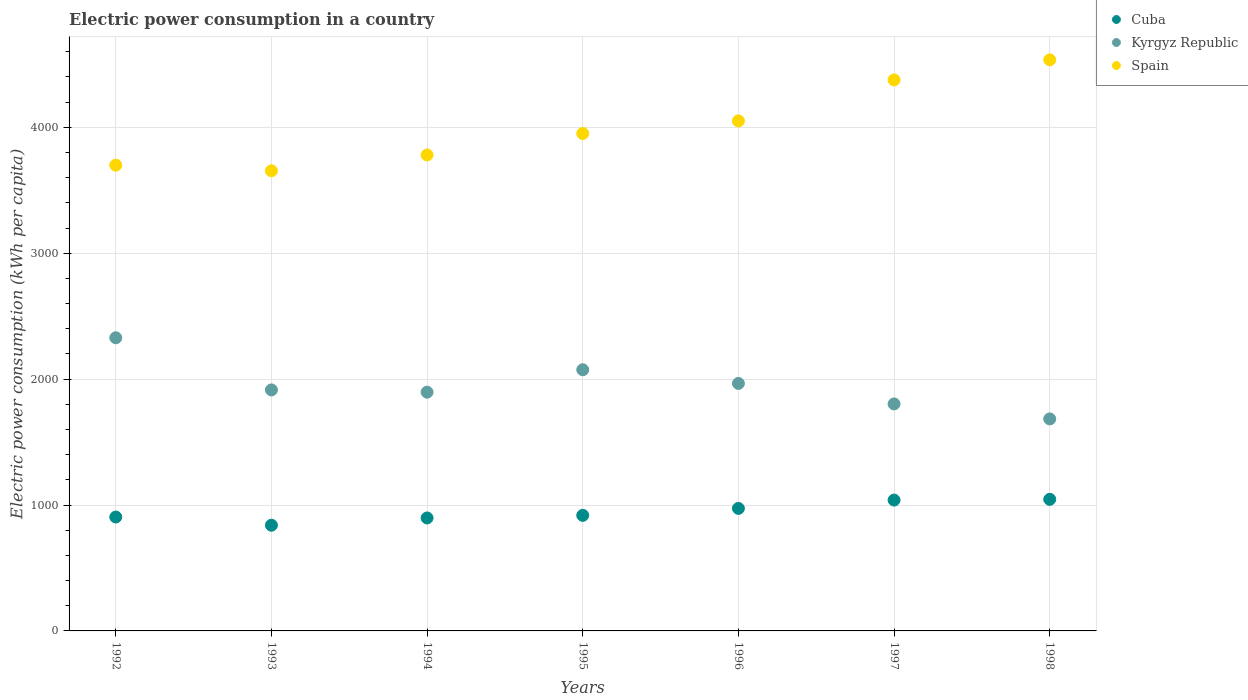Is the number of dotlines equal to the number of legend labels?
Keep it short and to the point. Yes. What is the electric power consumption in in Spain in 1997?
Ensure brevity in your answer.  4376.31. Across all years, what is the maximum electric power consumption in in Spain?
Give a very brief answer. 4535.7. Across all years, what is the minimum electric power consumption in in Spain?
Provide a short and direct response. 3654.48. In which year was the electric power consumption in in Kyrgyz Republic maximum?
Your answer should be very brief. 1992. In which year was the electric power consumption in in Cuba minimum?
Give a very brief answer. 1993. What is the total electric power consumption in in Cuba in the graph?
Your answer should be compact. 6616.54. What is the difference between the electric power consumption in in Cuba in 1994 and that in 1997?
Offer a very short reply. -142. What is the difference between the electric power consumption in in Cuba in 1994 and the electric power consumption in in Spain in 1996?
Offer a terse response. -3153.52. What is the average electric power consumption in in Spain per year?
Keep it short and to the point. 4006.79. In the year 1998, what is the difference between the electric power consumption in in Cuba and electric power consumption in in Spain?
Ensure brevity in your answer.  -3490.59. In how many years, is the electric power consumption in in Cuba greater than 3800 kWh per capita?
Ensure brevity in your answer.  0. What is the ratio of the electric power consumption in in Spain in 1992 to that in 1996?
Your response must be concise. 0.91. Is the electric power consumption in in Kyrgyz Republic in 1994 less than that in 1996?
Give a very brief answer. Yes. What is the difference between the highest and the second highest electric power consumption in in Spain?
Provide a succinct answer. 159.39. What is the difference between the highest and the lowest electric power consumption in in Kyrgyz Republic?
Keep it short and to the point. 644.25. Is the sum of the electric power consumption in in Cuba in 1993 and 1995 greater than the maximum electric power consumption in in Kyrgyz Republic across all years?
Offer a very short reply. No. Is the electric power consumption in in Kyrgyz Republic strictly less than the electric power consumption in in Cuba over the years?
Give a very brief answer. No. How many years are there in the graph?
Give a very brief answer. 7. What is the difference between two consecutive major ticks on the Y-axis?
Make the answer very short. 1000. Does the graph contain any zero values?
Your answer should be compact. No. Does the graph contain grids?
Give a very brief answer. Yes. What is the title of the graph?
Offer a very short reply. Electric power consumption in a country. What is the label or title of the Y-axis?
Keep it short and to the point. Electric power consumption (kWh per capita). What is the Electric power consumption (kWh per capita) of Cuba in 1992?
Provide a short and direct response. 904.55. What is the Electric power consumption (kWh per capita) in Kyrgyz Republic in 1992?
Provide a succinct answer. 2328.25. What is the Electric power consumption (kWh per capita) in Spain in 1992?
Provide a succinct answer. 3699.09. What is the Electric power consumption (kWh per capita) of Cuba in 1993?
Offer a very short reply. 839.54. What is the Electric power consumption (kWh per capita) in Kyrgyz Republic in 1993?
Your answer should be very brief. 1914.23. What is the Electric power consumption (kWh per capita) in Spain in 1993?
Your answer should be compact. 3654.48. What is the Electric power consumption (kWh per capita) in Cuba in 1994?
Keep it short and to the point. 897.23. What is the Electric power consumption (kWh per capita) of Kyrgyz Republic in 1994?
Offer a terse response. 1896.3. What is the Electric power consumption (kWh per capita) in Spain in 1994?
Your answer should be compact. 3780.33. What is the Electric power consumption (kWh per capita) of Cuba in 1995?
Provide a succinct answer. 917.84. What is the Electric power consumption (kWh per capita) in Kyrgyz Republic in 1995?
Provide a short and direct response. 2074.38. What is the Electric power consumption (kWh per capita) in Spain in 1995?
Your answer should be compact. 3950.85. What is the Electric power consumption (kWh per capita) in Cuba in 1996?
Offer a terse response. 973.04. What is the Electric power consumption (kWh per capita) in Kyrgyz Republic in 1996?
Make the answer very short. 1965.69. What is the Electric power consumption (kWh per capita) in Spain in 1996?
Make the answer very short. 4050.74. What is the Electric power consumption (kWh per capita) of Cuba in 1997?
Offer a terse response. 1039.23. What is the Electric power consumption (kWh per capita) of Kyrgyz Republic in 1997?
Offer a terse response. 1802.87. What is the Electric power consumption (kWh per capita) of Spain in 1997?
Your answer should be compact. 4376.31. What is the Electric power consumption (kWh per capita) in Cuba in 1998?
Provide a short and direct response. 1045.11. What is the Electric power consumption (kWh per capita) of Kyrgyz Republic in 1998?
Provide a succinct answer. 1684. What is the Electric power consumption (kWh per capita) of Spain in 1998?
Offer a very short reply. 4535.7. Across all years, what is the maximum Electric power consumption (kWh per capita) in Cuba?
Make the answer very short. 1045.11. Across all years, what is the maximum Electric power consumption (kWh per capita) in Kyrgyz Republic?
Your answer should be compact. 2328.25. Across all years, what is the maximum Electric power consumption (kWh per capita) of Spain?
Provide a short and direct response. 4535.7. Across all years, what is the minimum Electric power consumption (kWh per capita) in Cuba?
Your answer should be compact. 839.54. Across all years, what is the minimum Electric power consumption (kWh per capita) of Kyrgyz Republic?
Your answer should be compact. 1684. Across all years, what is the minimum Electric power consumption (kWh per capita) in Spain?
Make the answer very short. 3654.48. What is the total Electric power consumption (kWh per capita) in Cuba in the graph?
Your response must be concise. 6616.54. What is the total Electric power consumption (kWh per capita) of Kyrgyz Republic in the graph?
Your answer should be very brief. 1.37e+04. What is the total Electric power consumption (kWh per capita) of Spain in the graph?
Make the answer very short. 2.80e+04. What is the difference between the Electric power consumption (kWh per capita) in Cuba in 1992 and that in 1993?
Your response must be concise. 65. What is the difference between the Electric power consumption (kWh per capita) of Kyrgyz Republic in 1992 and that in 1993?
Keep it short and to the point. 414.02. What is the difference between the Electric power consumption (kWh per capita) of Spain in 1992 and that in 1993?
Give a very brief answer. 44.6. What is the difference between the Electric power consumption (kWh per capita) in Cuba in 1992 and that in 1994?
Ensure brevity in your answer.  7.32. What is the difference between the Electric power consumption (kWh per capita) in Kyrgyz Republic in 1992 and that in 1994?
Keep it short and to the point. 431.95. What is the difference between the Electric power consumption (kWh per capita) in Spain in 1992 and that in 1994?
Provide a short and direct response. -81.24. What is the difference between the Electric power consumption (kWh per capita) in Cuba in 1992 and that in 1995?
Give a very brief answer. -13.29. What is the difference between the Electric power consumption (kWh per capita) in Kyrgyz Republic in 1992 and that in 1995?
Your answer should be very brief. 253.88. What is the difference between the Electric power consumption (kWh per capita) in Spain in 1992 and that in 1995?
Offer a very short reply. -251.76. What is the difference between the Electric power consumption (kWh per capita) in Cuba in 1992 and that in 1996?
Offer a terse response. -68.49. What is the difference between the Electric power consumption (kWh per capita) in Kyrgyz Republic in 1992 and that in 1996?
Make the answer very short. 362.56. What is the difference between the Electric power consumption (kWh per capita) in Spain in 1992 and that in 1996?
Give a very brief answer. -351.66. What is the difference between the Electric power consumption (kWh per capita) in Cuba in 1992 and that in 1997?
Provide a short and direct response. -134.69. What is the difference between the Electric power consumption (kWh per capita) of Kyrgyz Republic in 1992 and that in 1997?
Offer a terse response. 525.38. What is the difference between the Electric power consumption (kWh per capita) in Spain in 1992 and that in 1997?
Make the answer very short. -677.23. What is the difference between the Electric power consumption (kWh per capita) in Cuba in 1992 and that in 1998?
Ensure brevity in your answer.  -140.56. What is the difference between the Electric power consumption (kWh per capita) in Kyrgyz Republic in 1992 and that in 1998?
Offer a terse response. 644.25. What is the difference between the Electric power consumption (kWh per capita) in Spain in 1992 and that in 1998?
Your answer should be very brief. -836.61. What is the difference between the Electric power consumption (kWh per capita) of Cuba in 1993 and that in 1994?
Make the answer very short. -57.69. What is the difference between the Electric power consumption (kWh per capita) of Kyrgyz Republic in 1993 and that in 1994?
Offer a terse response. 17.93. What is the difference between the Electric power consumption (kWh per capita) in Spain in 1993 and that in 1994?
Your response must be concise. -125.85. What is the difference between the Electric power consumption (kWh per capita) of Cuba in 1993 and that in 1995?
Make the answer very short. -78.3. What is the difference between the Electric power consumption (kWh per capita) of Kyrgyz Republic in 1993 and that in 1995?
Make the answer very short. -160.15. What is the difference between the Electric power consumption (kWh per capita) in Spain in 1993 and that in 1995?
Your response must be concise. -296.36. What is the difference between the Electric power consumption (kWh per capita) in Cuba in 1993 and that in 1996?
Ensure brevity in your answer.  -133.5. What is the difference between the Electric power consumption (kWh per capita) in Kyrgyz Republic in 1993 and that in 1996?
Keep it short and to the point. -51.46. What is the difference between the Electric power consumption (kWh per capita) of Spain in 1993 and that in 1996?
Offer a terse response. -396.26. What is the difference between the Electric power consumption (kWh per capita) of Cuba in 1993 and that in 1997?
Your answer should be compact. -199.69. What is the difference between the Electric power consumption (kWh per capita) in Kyrgyz Republic in 1993 and that in 1997?
Ensure brevity in your answer.  111.36. What is the difference between the Electric power consumption (kWh per capita) of Spain in 1993 and that in 1997?
Make the answer very short. -721.83. What is the difference between the Electric power consumption (kWh per capita) of Cuba in 1993 and that in 1998?
Make the answer very short. -205.57. What is the difference between the Electric power consumption (kWh per capita) of Kyrgyz Republic in 1993 and that in 1998?
Provide a succinct answer. 230.23. What is the difference between the Electric power consumption (kWh per capita) of Spain in 1993 and that in 1998?
Keep it short and to the point. -881.22. What is the difference between the Electric power consumption (kWh per capita) in Cuba in 1994 and that in 1995?
Give a very brief answer. -20.61. What is the difference between the Electric power consumption (kWh per capita) of Kyrgyz Republic in 1994 and that in 1995?
Make the answer very short. -178.08. What is the difference between the Electric power consumption (kWh per capita) of Spain in 1994 and that in 1995?
Your answer should be compact. -170.51. What is the difference between the Electric power consumption (kWh per capita) in Cuba in 1994 and that in 1996?
Provide a short and direct response. -75.81. What is the difference between the Electric power consumption (kWh per capita) of Kyrgyz Republic in 1994 and that in 1996?
Provide a succinct answer. -69.39. What is the difference between the Electric power consumption (kWh per capita) in Spain in 1994 and that in 1996?
Keep it short and to the point. -270.41. What is the difference between the Electric power consumption (kWh per capita) of Cuba in 1994 and that in 1997?
Provide a succinct answer. -142. What is the difference between the Electric power consumption (kWh per capita) in Kyrgyz Republic in 1994 and that in 1997?
Provide a short and direct response. 93.43. What is the difference between the Electric power consumption (kWh per capita) of Spain in 1994 and that in 1997?
Provide a succinct answer. -595.98. What is the difference between the Electric power consumption (kWh per capita) of Cuba in 1994 and that in 1998?
Keep it short and to the point. -147.88. What is the difference between the Electric power consumption (kWh per capita) in Kyrgyz Republic in 1994 and that in 1998?
Your answer should be compact. 212.3. What is the difference between the Electric power consumption (kWh per capita) in Spain in 1994 and that in 1998?
Your answer should be compact. -755.37. What is the difference between the Electric power consumption (kWh per capita) of Cuba in 1995 and that in 1996?
Your answer should be compact. -55.2. What is the difference between the Electric power consumption (kWh per capita) of Kyrgyz Republic in 1995 and that in 1996?
Make the answer very short. 108.69. What is the difference between the Electric power consumption (kWh per capita) in Spain in 1995 and that in 1996?
Give a very brief answer. -99.9. What is the difference between the Electric power consumption (kWh per capita) of Cuba in 1995 and that in 1997?
Ensure brevity in your answer.  -121.39. What is the difference between the Electric power consumption (kWh per capita) of Kyrgyz Republic in 1995 and that in 1997?
Provide a short and direct response. 271.51. What is the difference between the Electric power consumption (kWh per capita) in Spain in 1995 and that in 1997?
Give a very brief answer. -425.47. What is the difference between the Electric power consumption (kWh per capita) of Cuba in 1995 and that in 1998?
Your answer should be compact. -127.27. What is the difference between the Electric power consumption (kWh per capita) in Kyrgyz Republic in 1995 and that in 1998?
Your answer should be very brief. 390.38. What is the difference between the Electric power consumption (kWh per capita) of Spain in 1995 and that in 1998?
Provide a short and direct response. -584.85. What is the difference between the Electric power consumption (kWh per capita) of Cuba in 1996 and that in 1997?
Your answer should be compact. -66.19. What is the difference between the Electric power consumption (kWh per capita) in Kyrgyz Republic in 1996 and that in 1997?
Your response must be concise. 162.82. What is the difference between the Electric power consumption (kWh per capita) of Spain in 1996 and that in 1997?
Your answer should be compact. -325.57. What is the difference between the Electric power consumption (kWh per capita) of Cuba in 1996 and that in 1998?
Provide a short and direct response. -72.07. What is the difference between the Electric power consumption (kWh per capita) in Kyrgyz Republic in 1996 and that in 1998?
Give a very brief answer. 281.69. What is the difference between the Electric power consumption (kWh per capita) in Spain in 1996 and that in 1998?
Offer a terse response. -484.96. What is the difference between the Electric power consumption (kWh per capita) in Cuba in 1997 and that in 1998?
Keep it short and to the point. -5.88. What is the difference between the Electric power consumption (kWh per capita) in Kyrgyz Republic in 1997 and that in 1998?
Your answer should be compact. 118.87. What is the difference between the Electric power consumption (kWh per capita) in Spain in 1997 and that in 1998?
Your answer should be very brief. -159.39. What is the difference between the Electric power consumption (kWh per capita) of Cuba in 1992 and the Electric power consumption (kWh per capita) of Kyrgyz Republic in 1993?
Ensure brevity in your answer.  -1009.68. What is the difference between the Electric power consumption (kWh per capita) in Cuba in 1992 and the Electric power consumption (kWh per capita) in Spain in 1993?
Your answer should be compact. -2749.94. What is the difference between the Electric power consumption (kWh per capita) in Kyrgyz Republic in 1992 and the Electric power consumption (kWh per capita) in Spain in 1993?
Your response must be concise. -1326.23. What is the difference between the Electric power consumption (kWh per capita) of Cuba in 1992 and the Electric power consumption (kWh per capita) of Kyrgyz Republic in 1994?
Provide a succinct answer. -991.76. What is the difference between the Electric power consumption (kWh per capita) in Cuba in 1992 and the Electric power consumption (kWh per capita) in Spain in 1994?
Your response must be concise. -2875.79. What is the difference between the Electric power consumption (kWh per capita) of Kyrgyz Republic in 1992 and the Electric power consumption (kWh per capita) of Spain in 1994?
Your response must be concise. -1452.08. What is the difference between the Electric power consumption (kWh per capita) of Cuba in 1992 and the Electric power consumption (kWh per capita) of Kyrgyz Republic in 1995?
Ensure brevity in your answer.  -1169.83. What is the difference between the Electric power consumption (kWh per capita) of Cuba in 1992 and the Electric power consumption (kWh per capita) of Spain in 1995?
Offer a terse response. -3046.3. What is the difference between the Electric power consumption (kWh per capita) of Kyrgyz Republic in 1992 and the Electric power consumption (kWh per capita) of Spain in 1995?
Provide a succinct answer. -1622.59. What is the difference between the Electric power consumption (kWh per capita) of Cuba in 1992 and the Electric power consumption (kWh per capita) of Kyrgyz Republic in 1996?
Provide a succinct answer. -1061.14. What is the difference between the Electric power consumption (kWh per capita) in Cuba in 1992 and the Electric power consumption (kWh per capita) in Spain in 1996?
Your response must be concise. -3146.2. What is the difference between the Electric power consumption (kWh per capita) in Kyrgyz Republic in 1992 and the Electric power consumption (kWh per capita) in Spain in 1996?
Provide a succinct answer. -1722.49. What is the difference between the Electric power consumption (kWh per capita) in Cuba in 1992 and the Electric power consumption (kWh per capita) in Kyrgyz Republic in 1997?
Provide a short and direct response. -898.32. What is the difference between the Electric power consumption (kWh per capita) of Cuba in 1992 and the Electric power consumption (kWh per capita) of Spain in 1997?
Your response must be concise. -3471.77. What is the difference between the Electric power consumption (kWh per capita) in Kyrgyz Republic in 1992 and the Electric power consumption (kWh per capita) in Spain in 1997?
Provide a short and direct response. -2048.06. What is the difference between the Electric power consumption (kWh per capita) in Cuba in 1992 and the Electric power consumption (kWh per capita) in Kyrgyz Republic in 1998?
Offer a terse response. -779.46. What is the difference between the Electric power consumption (kWh per capita) of Cuba in 1992 and the Electric power consumption (kWh per capita) of Spain in 1998?
Offer a terse response. -3631.15. What is the difference between the Electric power consumption (kWh per capita) in Kyrgyz Republic in 1992 and the Electric power consumption (kWh per capita) in Spain in 1998?
Provide a succinct answer. -2207.44. What is the difference between the Electric power consumption (kWh per capita) in Cuba in 1993 and the Electric power consumption (kWh per capita) in Kyrgyz Republic in 1994?
Your answer should be compact. -1056.76. What is the difference between the Electric power consumption (kWh per capita) of Cuba in 1993 and the Electric power consumption (kWh per capita) of Spain in 1994?
Your response must be concise. -2940.79. What is the difference between the Electric power consumption (kWh per capita) of Kyrgyz Republic in 1993 and the Electric power consumption (kWh per capita) of Spain in 1994?
Ensure brevity in your answer.  -1866.1. What is the difference between the Electric power consumption (kWh per capita) of Cuba in 1993 and the Electric power consumption (kWh per capita) of Kyrgyz Republic in 1995?
Ensure brevity in your answer.  -1234.84. What is the difference between the Electric power consumption (kWh per capita) of Cuba in 1993 and the Electric power consumption (kWh per capita) of Spain in 1995?
Keep it short and to the point. -3111.3. What is the difference between the Electric power consumption (kWh per capita) of Kyrgyz Republic in 1993 and the Electric power consumption (kWh per capita) of Spain in 1995?
Ensure brevity in your answer.  -2036.62. What is the difference between the Electric power consumption (kWh per capita) in Cuba in 1993 and the Electric power consumption (kWh per capita) in Kyrgyz Republic in 1996?
Your response must be concise. -1126.15. What is the difference between the Electric power consumption (kWh per capita) of Cuba in 1993 and the Electric power consumption (kWh per capita) of Spain in 1996?
Your answer should be compact. -3211.2. What is the difference between the Electric power consumption (kWh per capita) of Kyrgyz Republic in 1993 and the Electric power consumption (kWh per capita) of Spain in 1996?
Keep it short and to the point. -2136.51. What is the difference between the Electric power consumption (kWh per capita) in Cuba in 1993 and the Electric power consumption (kWh per capita) in Kyrgyz Republic in 1997?
Your answer should be compact. -963.33. What is the difference between the Electric power consumption (kWh per capita) of Cuba in 1993 and the Electric power consumption (kWh per capita) of Spain in 1997?
Give a very brief answer. -3536.77. What is the difference between the Electric power consumption (kWh per capita) in Kyrgyz Republic in 1993 and the Electric power consumption (kWh per capita) in Spain in 1997?
Provide a succinct answer. -2462.08. What is the difference between the Electric power consumption (kWh per capita) of Cuba in 1993 and the Electric power consumption (kWh per capita) of Kyrgyz Republic in 1998?
Keep it short and to the point. -844.46. What is the difference between the Electric power consumption (kWh per capita) of Cuba in 1993 and the Electric power consumption (kWh per capita) of Spain in 1998?
Offer a terse response. -3696.16. What is the difference between the Electric power consumption (kWh per capita) in Kyrgyz Republic in 1993 and the Electric power consumption (kWh per capita) in Spain in 1998?
Your answer should be very brief. -2621.47. What is the difference between the Electric power consumption (kWh per capita) in Cuba in 1994 and the Electric power consumption (kWh per capita) in Kyrgyz Republic in 1995?
Offer a very short reply. -1177.15. What is the difference between the Electric power consumption (kWh per capita) in Cuba in 1994 and the Electric power consumption (kWh per capita) in Spain in 1995?
Your answer should be compact. -3053.62. What is the difference between the Electric power consumption (kWh per capita) of Kyrgyz Republic in 1994 and the Electric power consumption (kWh per capita) of Spain in 1995?
Ensure brevity in your answer.  -2054.54. What is the difference between the Electric power consumption (kWh per capita) in Cuba in 1994 and the Electric power consumption (kWh per capita) in Kyrgyz Republic in 1996?
Provide a short and direct response. -1068.46. What is the difference between the Electric power consumption (kWh per capita) in Cuba in 1994 and the Electric power consumption (kWh per capita) in Spain in 1996?
Provide a succinct answer. -3153.52. What is the difference between the Electric power consumption (kWh per capita) of Kyrgyz Republic in 1994 and the Electric power consumption (kWh per capita) of Spain in 1996?
Your answer should be compact. -2154.44. What is the difference between the Electric power consumption (kWh per capita) in Cuba in 1994 and the Electric power consumption (kWh per capita) in Kyrgyz Republic in 1997?
Your answer should be very brief. -905.64. What is the difference between the Electric power consumption (kWh per capita) in Cuba in 1994 and the Electric power consumption (kWh per capita) in Spain in 1997?
Make the answer very short. -3479.08. What is the difference between the Electric power consumption (kWh per capita) of Kyrgyz Republic in 1994 and the Electric power consumption (kWh per capita) of Spain in 1997?
Your answer should be compact. -2480.01. What is the difference between the Electric power consumption (kWh per capita) of Cuba in 1994 and the Electric power consumption (kWh per capita) of Kyrgyz Republic in 1998?
Offer a terse response. -786.77. What is the difference between the Electric power consumption (kWh per capita) of Cuba in 1994 and the Electric power consumption (kWh per capita) of Spain in 1998?
Ensure brevity in your answer.  -3638.47. What is the difference between the Electric power consumption (kWh per capita) in Kyrgyz Republic in 1994 and the Electric power consumption (kWh per capita) in Spain in 1998?
Provide a succinct answer. -2639.4. What is the difference between the Electric power consumption (kWh per capita) of Cuba in 1995 and the Electric power consumption (kWh per capita) of Kyrgyz Republic in 1996?
Provide a succinct answer. -1047.85. What is the difference between the Electric power consumption (kWh per capita) in Cuba in 1995 and the Electric power consumption (kWh per capita) in Spain in 1996?
Ensure brevity in your answer.  -3132.9. What is the difference between the Electric power consumption (kWh per capita) in Kyrgyz Republic in 1995 and the Electric power consumption (kWh per capita) in Spain in 1996?
Your answer should be compact. -1976.36. What is the difference between the Electric power consumption (kWh per capita) of Cuba in 1995 and the Electric power consumption (kWh per capita) of Kyrgyz Republic in 1997?
Provide a short and direct response. -885.03. What is the difference between the Electric power consumption (kWh per capita) in Cuba in 1995 and the Electric power consumption (kWh per capita) in Spain in 1997?
Your answer should be very brief. -3458.47. What is the difference between the Electric power consumption (kWh per capita) in Kyrgyz Republic in 1995 and the Electric power consumption (kWh per capita) in Spain in 1997?
Your answer should be very brief. -2301.93. What is the difference between the Electric power consumption (kWh per capita) in Cuba in 1995 and the Electric power consumption (kWh per capita) in Kyrgyz Republic in 1998?
Your answer should be compact. -766.16. What is the difference between the Electric power consumption (kWh per capita) in Cuba in 1995 and the Electric power consumption (kWh per capita) in Spain in 1998?
Make the answer very short. -3617.86. What is the difference between the Electric power consumption (kWh per capita) in Kyrgyz Republic in 1995 and the Electric power consumption (kWh per capita) in Spain in 1998?
Provide a succinct answer. -2461.32. What is the difference between the Electric power consumption (kWh per capita) in Cuba in 1996 and the Electric power consumption (kWh per capita) in Kyrgyz Republic in 1997?
Give a very brief answer. -829.83. What is the difference between the Electric power consumption (kWh per capita) in Cuba in 1996 and the Electric power consumption (kWh per capita) in Spain in 1997?
Offer a very short reply. -3403.27. What is the difference between the Electric power consumption (kWh per capita) in Kyrgyz Republic in 1996 and the Electric power consumption (kWh per capita) in Spain in 1997?
Ensure brevity in your answer.  -2410.62. What is the difference between the Electric power consumption (kWh per capita) of Cuba in 1996 and the Electric power consumption (kWh per capita) of Kyrgyz Republic in 1998?
Give a very brief answer. -710.96. What is the difference between the Electric power consumption (kWh per capita) in Cuba in 1996 and the Electric power consumption (kWh per capita) in Spain in 1998?
Offer a terse response. -3562.66. What is the difference between the Electric power consumption (kWh per capita) in Kyrgyz Republic in 1996 and the Electric power consumption (kWh per capita) in Spain in 1998?
Give a very brief answer. -2570.01. What is the difference between the Electric power consumption (kWh per capita) in Cuba in 1997 and the Electric power consumption (kWh per capita) in Kyrgyz Republic in 1998?
Give a very brief answer. -644.77. What is the difference between the Electric power consumption (kWh per capita) in Cuba in 1997 and the Electric power consumption (kWh per capita) in Spain in 1998?
Your response must be concise. -3496.47. What is the difference between the Electric power consumption (kWh per capita) in Kyrgyz Republic in 1997 and the Electric power consumption (kWh per capita) in Spain in 1998?
Offer a terse response. -2732.83. What is the average Electric power consumption (kWh per capita) in Cuba per year?
Provide a succinct answer. 945.22. What is the average Electric power consumption (kWh per capita) of Kyrgyz Republic per year?
Provide a succinct answer. 1952.25. What is the average Electric power consumption (kWh per capita) in Spain per year?
Ensure brevity in your answer.  4006.79. In the year 1992, what is the difference between the Electric power consumption (kWh per capita) in Cuba and Electric power consumption (kWh per capita) in Kyrgyz Republic?
Ensure brevity in your answer.  -1423.71. In the year 1992, what is the difference between the Electric power consumption (kWh per capita) of Cuba and Electric power consumption (kWh per capita) of Spain?
Offer a terse response. -2794.54. In the year 1992, what is the difference between the Electric power consumption (kWh per capita) in Kyrgyz Republic and Electric power consumption (kWh per capita) in Spain?
Offer a very short reply. -1370.83. In the year 1993, what is the difference between the Electric power consumption (kWh per capita) in Cuba and Electric power consumption (kWh per capita) in Kyrgyz Republic?
Offer a very short reply. -1074.69. In the year 1993, what is the difference between the Electric power consumption (kWh per capita) of Cuba and Electric power consumption (kWh per capita) of Spain?
Make the answer very short. -2814.94. In the year 1993, what is the difference between the Electric power consumption (kWh per capita) of Kyrgyz Republic and Electric power consumption (kWh per capita) of Spain?
Provide a succinct answer. -1740.25. In the year 1994, what is the difference between the Electric power consumption (kWh per capita) of Cuba and Electric power consumption (kWh per capita) of Kyrgyz Republic?
Offer a very short reply. -999.08. In the year 1994, what is the difference between the Electric power consumption (kWh per capita) in Cuba and Electric power consumption (kWh per capita) in Spain?
Make the answer very short. -2883.1. In the year 1994, what is the difference between the Electric power consumption (kWh per capita) of Kyrgyz Republic and Electric power consumption (kWh per capita) of Spain?
Ensure brevity in your answer.  -1884.03. In the year 1995, what is the difference between the Electric power consumption (kWh per capita) of Cuba and Electric power consumption (kWh per capita) of Kyrgyz Republic?
Make the answer very short. -1156.54. In the year 1995, what is the difference between the Electric power consumption (kWh per capita) of Cuba and Electric power consumption (kWh per capita) of Spain?
Keep it short and to the point. -3033.01. In the year 1995, what is the difference between the Electric power consumption (kWh per capita) in Kyrgyz Republic and Electric power consumption (kWh per capita) in Spain?
Your answer should be compact. -1876.47. In the year 1996, what is the difference between the Electric power consumption (kWh per capita) of Cuba and Electric power consumption (kWh per capita) of Kyrgyz Republic?
Ensure brevity in your answer.  -992.65. In the year 1996, what is the difference between the Electric power consumption (kWh per capita) of Cuba and Electric power consumption (kWh per capita) of Spain?
Offer a terse response. -3077.7. In the year 1996, what is the difference between the Electric power consumption (kWh per capita) in Kyrgyz Republic and Electric power consumption (kWh per capita) in Spain?
Your answer should be very brief. -2085.05. In the year 1997, what is the difference between the Electric power consumption (kWh per capita) of Cuba and Electric power consumption (kWh per capita) of Kyrgyz Republic?
Offer a very short reply. -763.64. In the year 1997, what is the difference between the Electric power consumption (kWh per capita) in Cuba and Electric power consumption (kWh per capita) in Spain?
Offer a terse response. -3337.08. In the year 1997, what is the difference between the Electric power consumption (kWh per capita) in Kyrgyz Republic and Electric power consumption (kWh per capita) in Spain?
Offer a very short reply. -2573.44. In the year 1998, what is the difference between the Electric power consumption (kWh per capita) of Cuba and Electric power consumption (kWh per capita) of Kyrgyz Republic?
Offer a very short reply. -638.89. In the year 1998, what is the difference between the Electric power consumption (kWh per capita) in Cuba and Electric power consumption (kWh per capita) in Spain?
Ensure brevity in your answer.  -3490.59. In the year 1998, what is the difference between the Electric power consumption (kWh per capita) in Kyrgyz Republic and Electric power consumption (kWh per capita) in Spain?
Keep it short and to the point. -2851.7. What is the ratio of the Electric power consumption (kWh per capita) in Cuba in 1992 to that in 1993?
Ensure brevity in your answer.  1.08. What is the ratio of the Electric power consumption (kWh per capita) in Kyrgyz Republic in 1992 to that in 1993?
Provide a short and direct response. 1.22. What is the ratio of the Electric power consumption (kWh per capita) of Spain in 1992 to that in 1993?
Make the answer very short. 1.01. What is the ratio of the Electric power consumption (kWh per capita) in Cuba in 1992 to that in 1994?
Keep it short and to the point. 1.01. What is the ratio of the Electric power consumption (kWh per capita) of Kyrgyz Republic in 1992 to that in 1994?
Offer a very short reply. 1.23. What is the ratio of the Electric power consumption (kWh per capita) of Spain in 1992 to that in 1994?
Your answer should be very brief. 0.98. What is the ratio of the Electric power consumption (kWh per capita) of Cuba in 1992 to that in 1995?
Offer a terse response. 0.99. What is the ratio of the Electric power consumption (kWh per capita) of Kyrgyz Republic in 1992 to that in 1995?
Your answer should be compact. 1.12. What is the ratio of the Electric power consumption (kWh per capita) of Spain in 1992 to that in 1995?
Your response must be concise. 0.94. What is the ratio of the Electric power consumption (kWh per capita) of Cuba in 1992 to that in 1996?
Offer a terse response. 0.93. What is the ratio of the Electric power consumption (kWh per capita) in Kyrgyz Republic in 1992 to that in 1996?
Provide a short and direct response. 1.18. What is the ratio of the Electric power consumption (kWh per capita) in Spain in 1992 to that in 1996?
Your answer should be compact. 0.91. What is the ratio of the Electric power consumption (kWh per capita) of Cuba in 1992 to that in 1997?
Give a very brief answer. 0.87. What is the ratio of the Electric power consumption (kWh per capita) of Kyrgyz Republic in 1992 to that in 1997?
Offer a very short reply. 1.29. What is the ratio of the Electric power consumption (kWh per capita) of Spain in 1992 to that in 1997?
Provide a short and direct response. 0.85. What is the ratio of the Electric power consumption (kWh per capita) in Cuba in 1992 to that in 1998?
Your answer should be compact. 0.87. What is the ratio of the Electric power consumption (kWh per capita) in Kyrgyz Republic in 1992 to that in 1998?
Offer a very short reply. 1.38. What is the ratio of the Electric power consumption (kWh per capita) in Spain in 1992 to that in 1998?
Provide a short and direct response. 0.82. What is the ratio of the Electric power consumption (kWh per capita) of Cuba in 1993 to that in 1994?
Give a very brief answer. 0.94. What is the ratio of the Electric power consumption (kWh per capita) in Kyrgyz Republic in 1993 to that in 1994?
Provide a short and direct response. 1.01. What is the ratio of the Electric power consumption (kWh per capita) of Spain in 1993 to that in 1994?
Ensure brevity in your answer.  0.97. What is the ratio of the Electric power consumption (kWh per capita) in Cuba in 1993 to that in 1995?
Provide a succinct answer. 0.91. What is the ratio of the Electric power consumption (kWh per capita) in Kyrgyz Republic in 1993 to that in 1995?
Your answer should be compact. 0.92. What is the ratio of the Electric power consumption (kWh per capita) of Spain in 1993 to that in 1995?
Provide a succinct answer. 0.93. What is the ratio of the Electric power consumption (kWh per capita) of Cuba in 1993 to that in 1996?
Your answer should be compact. 0.86. What is the ratio of the Electric power consumption (kWh per capita) in Kyrgyz Republic in 1993 to that in 1996?
Provide a short and direct response. 0.97. What is the ratio of the Electric power consumption (kWh per capita) in Spain in 1993 to that in 1996?
Ensure brevity in your answer.  0.9. What is the ratio of the Electric power consumption (kWh per capita) in Cuba in 1993 to that in 1997?
Give a very brief answer. 0.81. What is the ratio of the Electric power consumption (kWh per capita) in Kyrgyz Republic in 1993 to that in 1997?
Keep it short and to the point. 1.06. What is the ratio of the Electric power consumption (kWh per capita) in Spain in 1993 to that in 1997?
Your answer should be compact. 0.84. What is the ratio of the Electric power consumption (kWh per capita) of Cuba in 1993 to that in 1998?
Your answer should be compact. 0.8. What is the ratio of the Electric power consumption (kWh per capita) of Kyrgyz Republic in 1993 to that in 1998?
Your answer should be compact. 1.14. What is the ratio of the Electric power consumption (kWh per capita) of Spain in 1993 to that in 1998?
Provide a succinct answer. 0.81. What is the ratio of the Electric power consumption (kWh per capita) of Cuba in 1994 to that in 1995?
Provide a succinct answer. 0.98. What is the ratio of the Electric power consumption (kWh per capita) of Kyrgyz Republic in 1994 to that in 1995?
Make the answer very short. 0.91. What is the ratio of the Electric power consumption (kWh per capita) of Spain in 1994 to that in 1995?
Give a very brief answer. 0.96. What is the ratio of the Electric power consumption (kWh per capita) of Cuba in 1994 to that in 1996?
Offer a very short reply. 0.92. What is the ratio of the Electric power consumption (kWh per capita) of Kyrgyz Republic in 1994 to that in 1996?
Your answer should be compact. 0.96. What is the ratio of the Electric power consumption (kWh per capita) in Spain in 1994 to that in 1996?
Provide a short and direct response. 0.93. What is the ratio of the Electric power consumption (kWh per capita) in Cuba in 1994 to that in 1997?
Give a very brief answer. 0.86. What is the ratio of the Electric power consumption (kWh per capita) of Kyrgyz Republic in 1994 to that in 1997?
Provide a short and direct response. 1.05. What is the ratio of the Electric power consumption (kWh per capita) in Spain in 1994 to that in 1997?
Your response must be concise. 0.86. What is the ratio of the Electric power consumption (kWh per capita) in Cuba in 1994 to that in 1998?
Your answer should be compact. 0.86. What is the ratio of the Electric power consumption (kWh per capita) in Kyrgyz Republic in 1994 to that in 1998?
Offer a terse response. 1.13. What is the ratio of the Electric power consumption (kWh per capita) of Spain in 1994 to that in 1998?
Offer a terse response. 0.83. What is the ratio of the Electric power consumption (kWh per capita) of Cuba in 1995 to that in 1996?
Ensure brevity in your answer.  0.94. What is the ratio of the Electric power consumption (kWh per capita) in Kyrgyz Republic in 1995 to that in 1996?
Your answer should be very brief. 1.06. What is the ratio of the Electric power consumption (kWh per capita) of Spain in 1995 to that in 1996?
Provide a succinct answer. 0.98. What is the ratio of the Electric power consumption (kWh per capita) in Cuba in 1995 to that in 1997?
Your response must be concise. 0.88. What is the ratio of the Electric power consumption (kWh per capita) in Kyrgyz Republic in 1995 to that in 1997?
Give a very brief answer. 1.15. What is the ratio of the Electric power consumption (kWh per capita) in Spain in 1995 to that in 1997?
Give a very brief answer. 0.9. What is the ratio of the Electric power consumption (kWh per capita) in Cuba in 1995 to that in 1998?
Keep it short and to the point. 0.88. What is the ratio of the Electric power consumption (kWh per capita) of Kyrgyz Republic in 1995 to that in 1998?
Offer a very short reply. 1.23. What is the ratio of the Electric power consumption (kWh per capita) in Spain in 1995 to that in 1998?
Make the answer very short. 0.87. What is the ratio of the Electric power consumption (kWh per capita) in Cuba in 1996 to that in 1997?
Your answer should be compact. 0.94. What is the ratio of the Electric power consumption (kWh per capita) in Kyrgyz Republic in 1996 to that in 1997?
Provide a short and direct response. 1.09. What is the ratio of the Electric power consumption (kWh per capita) in Spain in 1996 to that in 1997?
Make the answer very short. 0.93. What is the ratio of the Electric power consumption (kWh per capita) in Kyrgyz Republic in 1996 to that in 1998?
Your answer should be very brief. 1.17. What is the ratio of the Electric power consumption (kWh per capita) in Spain in 1996 to that in 1998?
Offer a terse response. 0.89. What is the ratio of the Electric power consumption (kWh per capita) in Cuba in 1997 to that in 1998?
Your answer should be very brief. 0.99. What is the ratio of the Electric power consumption (kWh per capita) of Kyrgyz Republic in 1997 to that in 1998?
Your response must be concise. 1.07. What is the ratio of the Electric power consumption (kWh per capita) in Spain in 1997 to that in 1998?
Your answer should be compact. 0.96. What is the difference between the highest and the second highest Electric power consumption (kWh per capita) of Cuba?
Provide a short and direct response. 5.88. What is the difference between the highest and the second highest Electric power consumption (kWh per capita) of Kyrgyz Republic?
Give a very brief answer. 253.88. What is the difference between the highest and the second highest Electric power consumption (kWh per capita) of Spain?
Your answer should be very brief. 159.39. What is the difference between the highest and the lowest Electric power consumption (kWh per capita) of Cuba?
Ensure brevity in your answer.  205.57. What is the difference between the highest and the lowest Electric power consumption (kWh per capita) of Kyrgyz Republic?
Offer a terse response. 644.25. What is the difference between the highest and the lowest Electric power consumption (kWh per capita) in Spain?
Your answer should be very brief. 881.22. 